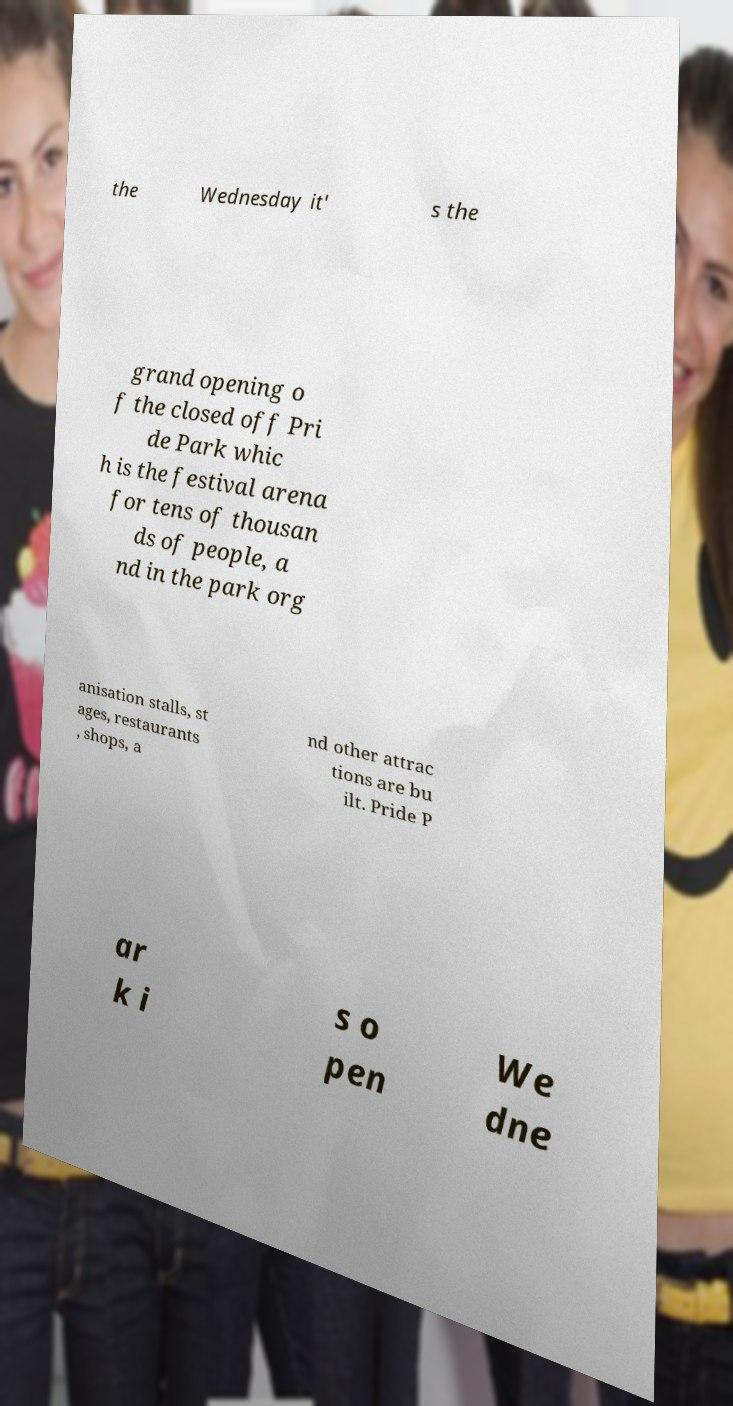For documentation purposes, I need the text within this image transcribed. Could you provide that? the Wednesday it' s the grand opening o f the closed off Pri de Park whic h is the festival arena for tens of thousan ds of people, a nd in the park org anisation stalls, st ages, restaurants , shops, a nd other attrac tions are bu ilt. Pride P ar k i s o pen We dne 